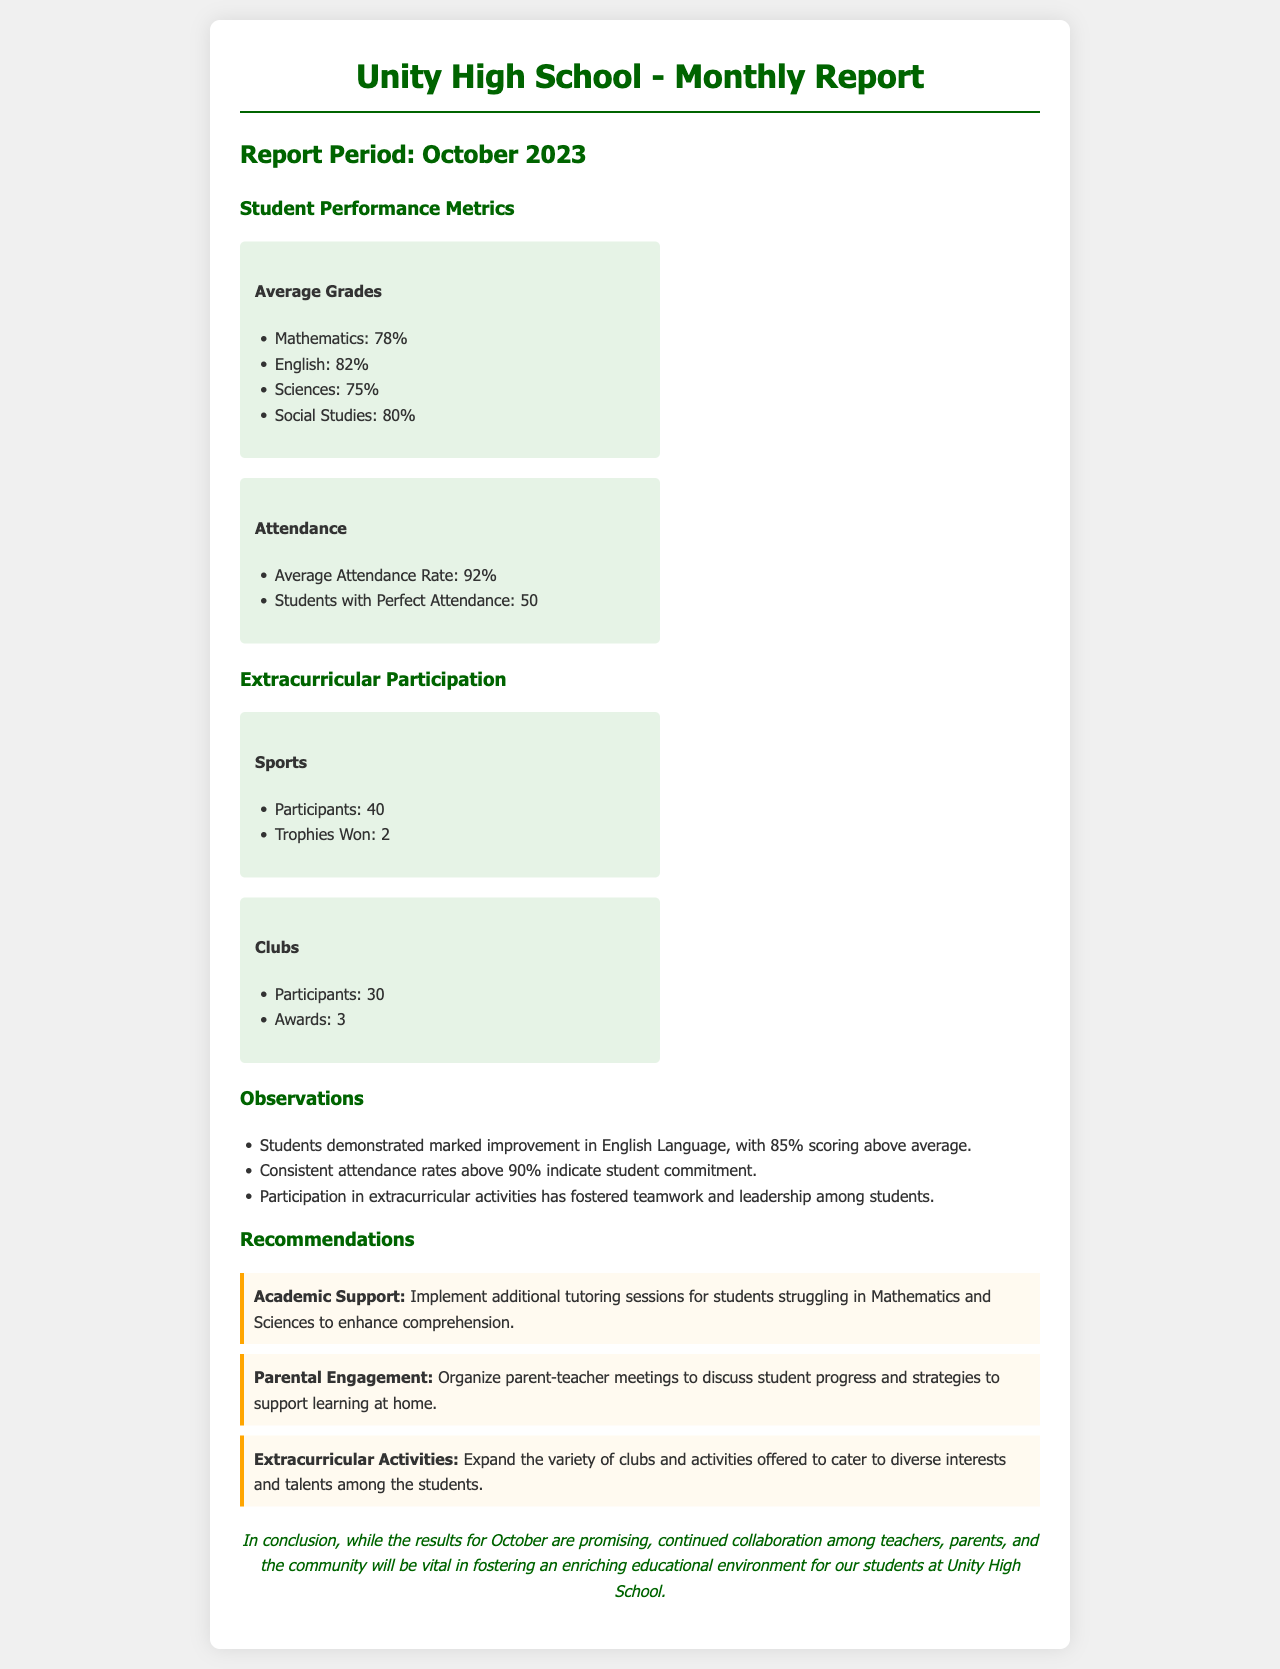What was the average grade in Mathematics? The average grade in Mathematics is specifically mentioned in the metrics section of the report.
Answer: 78% How many students had perfect attendance? The document states the count of students with perfect attendance in the attendance metrics.
Answer: 50 What percentage of students scored above average in English? The observation section notes that a significant percentage of students scored above average in English, suggesting improvement.
Answer: 85% How many trophies did the sports participants win? The number of trophies won is explicitly stated in the sports participation metrics.
Answer: 2 What is the average attendance rate for the month? The average attendance rate is provided in the attendance metrics of the report.
Answer: 92% What kind of support is recommended for students struggling in Mathematics? The recommendations specify the type of support to help struggling students in Mathematics.
Answer: Additional tutoring sessions How many awards did the clubs receive? The number of awards won by clubs is clearly mentioned in the clubs participation metrics.
Answer: 3 What month and year does this report cover? The report period is stated at the top of the document.
Answer: October 2023 What is emphasized as important for the students' educational environment? The closing statement highlights a specific element that is vital for the students' education.
Answer: Collaboration among teachers, parents, and the community 